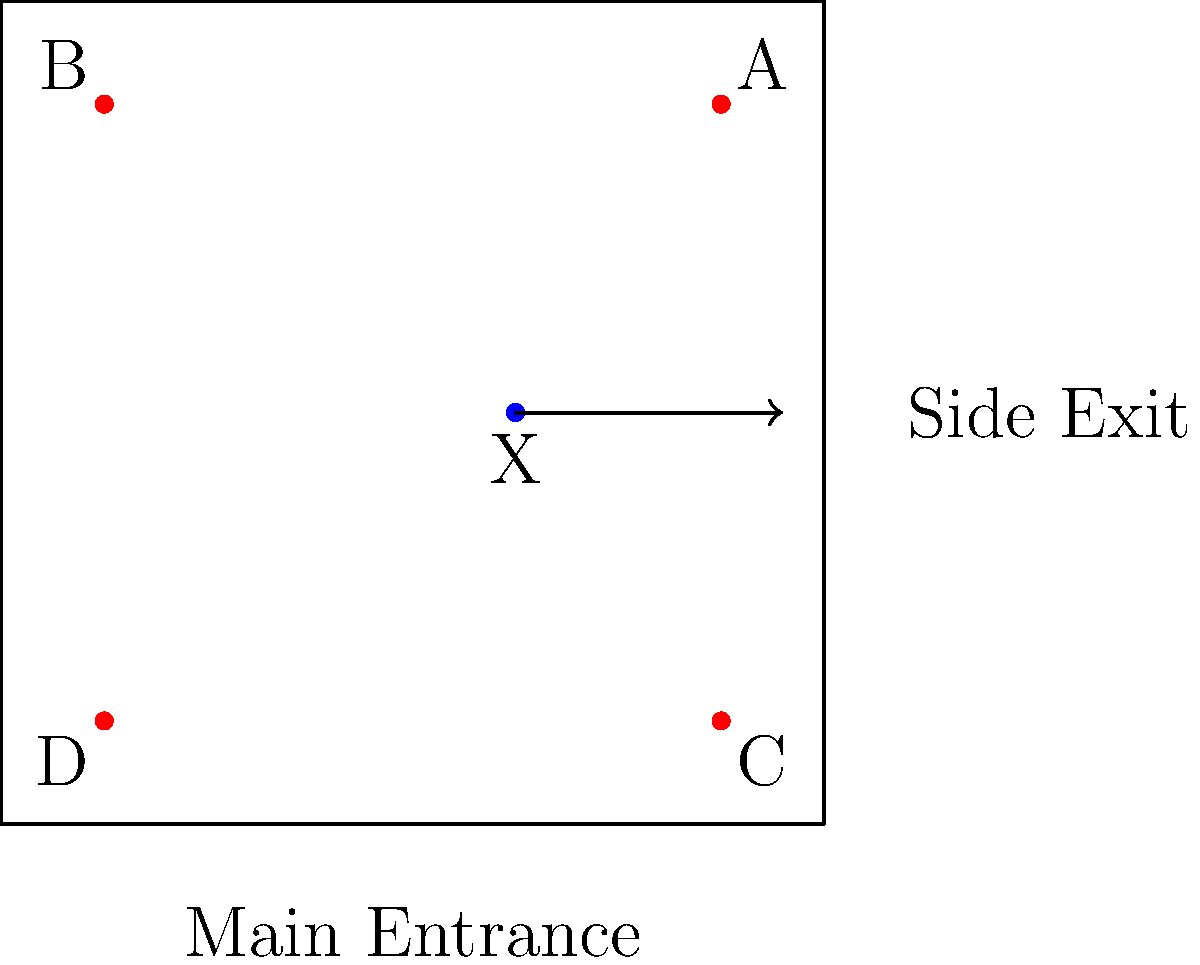In the security camera layout shown, a suspicious individual (marked as X) is observed moving towards the side exit. Which camera(s) should be prioritized for tracking this person's movement, and what immediate action should be taken? To answer this question, we need to analyze the layout and the movement of the suspicious individual:

1. Identify the position of the suspicious individual:
   - The person (X) is located near the center of the room, slightly to the right.

2. Determine the direction of movement:
   - The arrow indicates movement towards the right, in the direction of the side exit.

3. Assess the camera positions:
   - Camera A: top-right corner
   - Camera B: top-left corner
   - Camera C: bottom-right corner
   - Camera D: bottom-left corner

4. Prioritize cameras based on the individual's position and movement:
   - Camera A and C are on the right side, closer to the individual's path.
   - Camera A has the best view of the area between the individual and the side exit.
   - Camera C can provide a secondary angle if the person changes direction.

5. Determine immediate action:
   - Alert security personnel to monitor Cameras A and C closely.
   - Prepare to intercept the individual before they reach the side exit.

Therefore, the priority should be given to Cameras A and C, with immediate action to alert security personnel for potential interception.
Answer: Prioritize Cameras A and C; alert security for potential interception. 